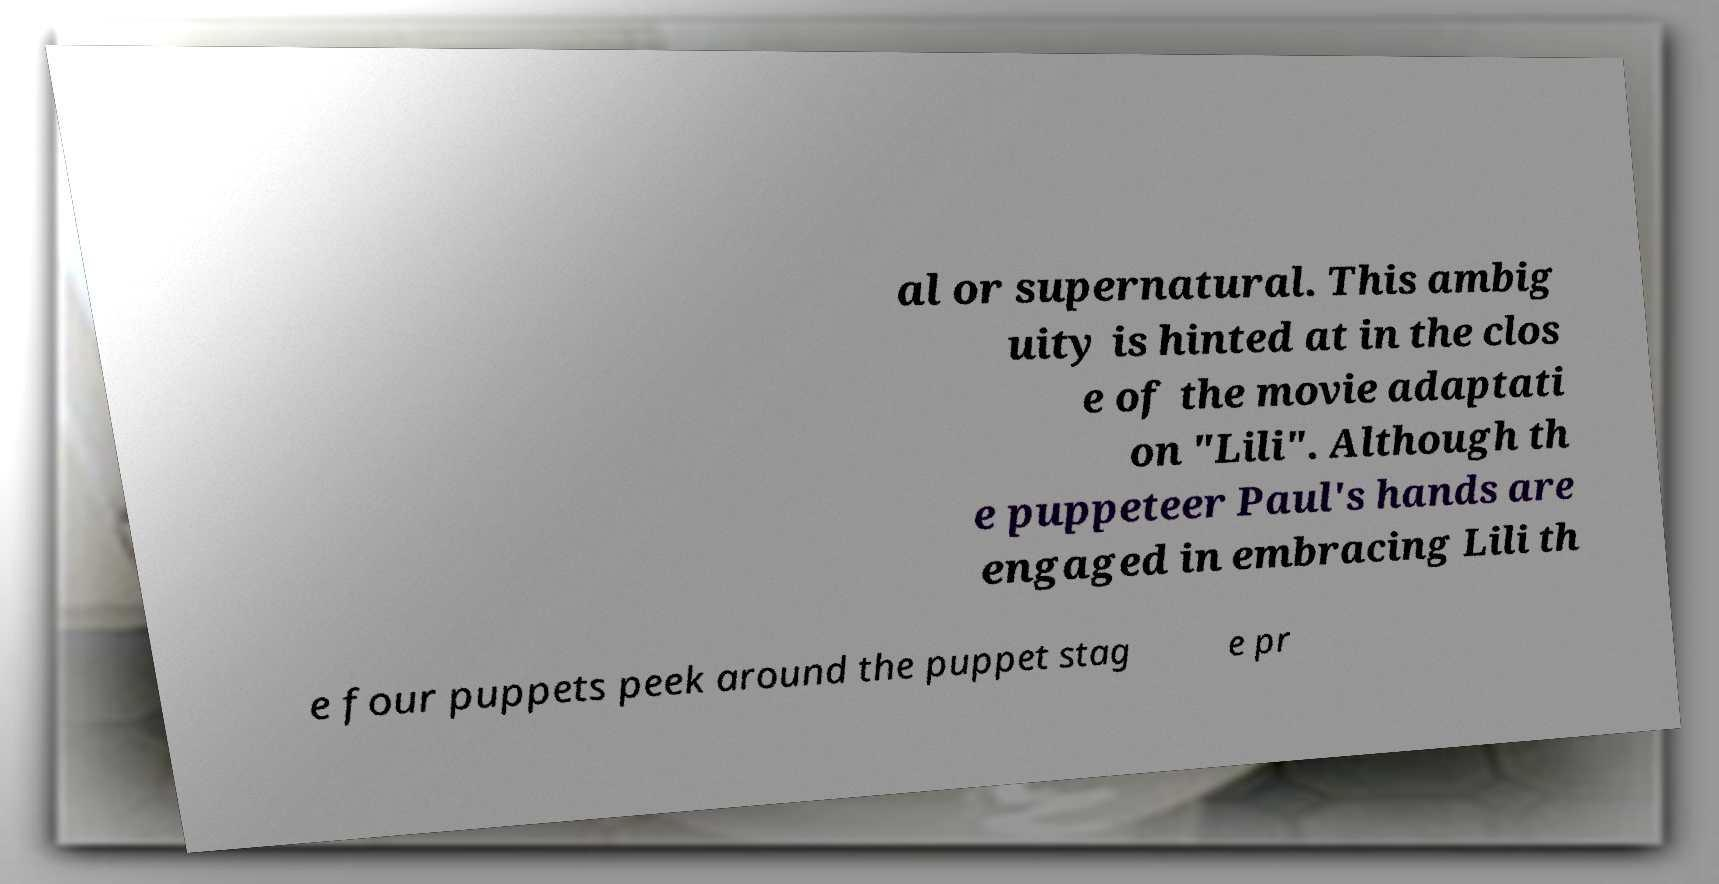What messages or text are displayed in this image? I need them in a readable, typed format. al or supernatural. This ambig uity is hinted at in the clos e of the movie adaptati on "Lili". Although th e puppeteer Paul's hands are engaged in embracing Lili th e four puppets peek around the puppet stag e pr 